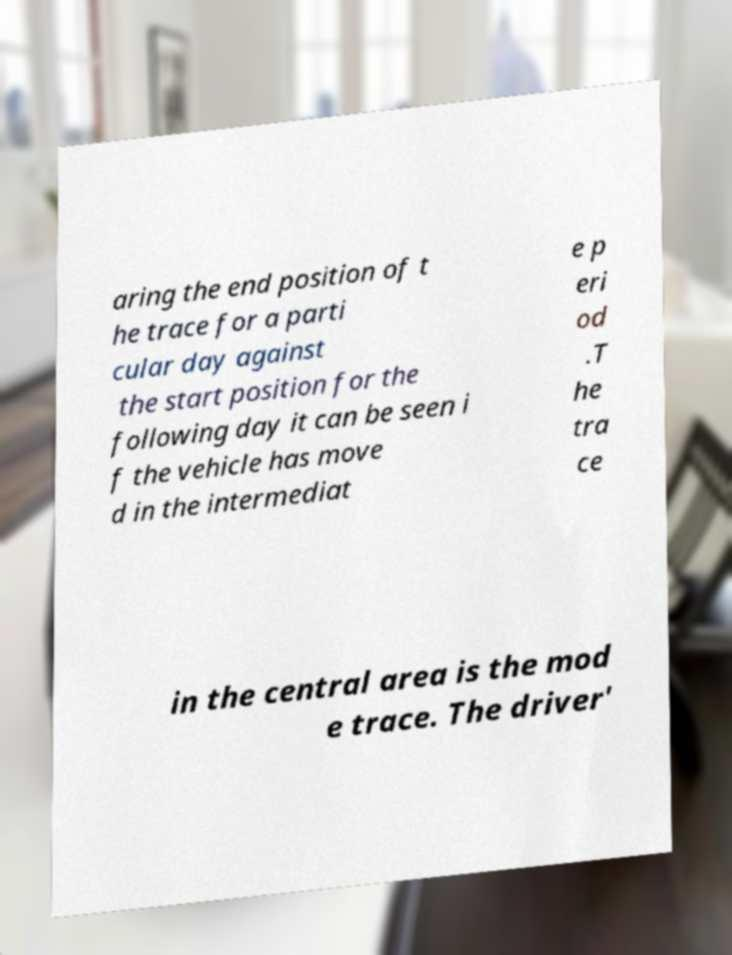What messages or text are displayed in this image? I need them in a readable, typed format. aring the end position of t he trace for a parti cular day against the start position for the following day it can be seen i f the vehicle has move d in the intermediat e p eri od .T he tra ce in the central area is the mod e trace. The driver' 